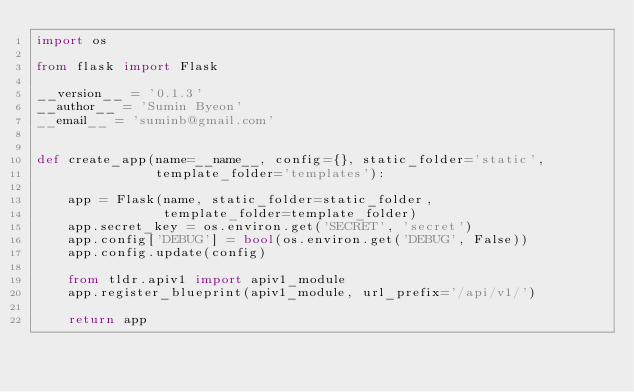Convert code to text. <code><loc_0><loc_0><loc_500><loc_500><_Python_>import os

from flask import Flask

__version__ = '0.1.3'
__author__ = 'Sumin Byeon'
__email__ = 'suminb@gmail.com'


def create_app(name=__name__, config={}, static_folder='static',
               template_folder='templates'):

    app = Flask(name, static_folder=static_folder,
                template_folder=template_folder)
    app.secret_key = os.environ.get('SECRET', 'secret')
    app.config['DEBUG'] = bool(os.environ.get('DEBUG', False))
    app.config.update(config)

    from tldr.apiv1 import apiv1_module
    app.register_blueprint(apiv1_module, url_prefix='/api/v1/')

    return app
</code> 